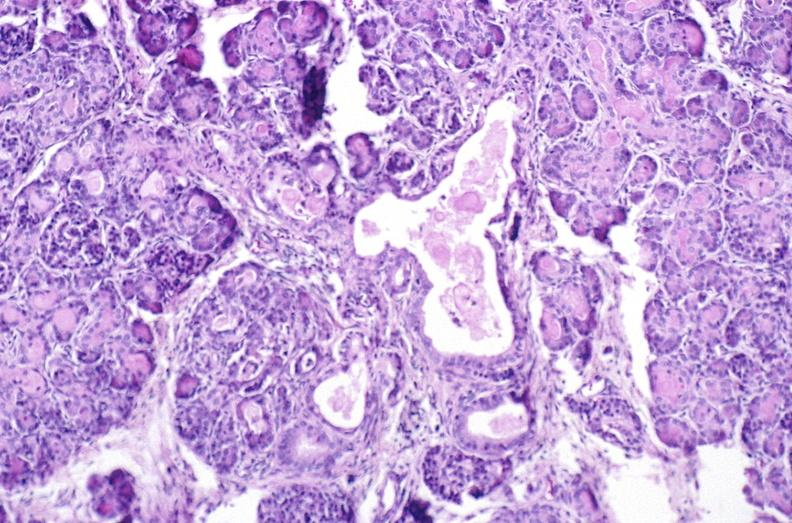does this image show cystic fibrosis?
Answer the question using a single word or phrase. Yes 